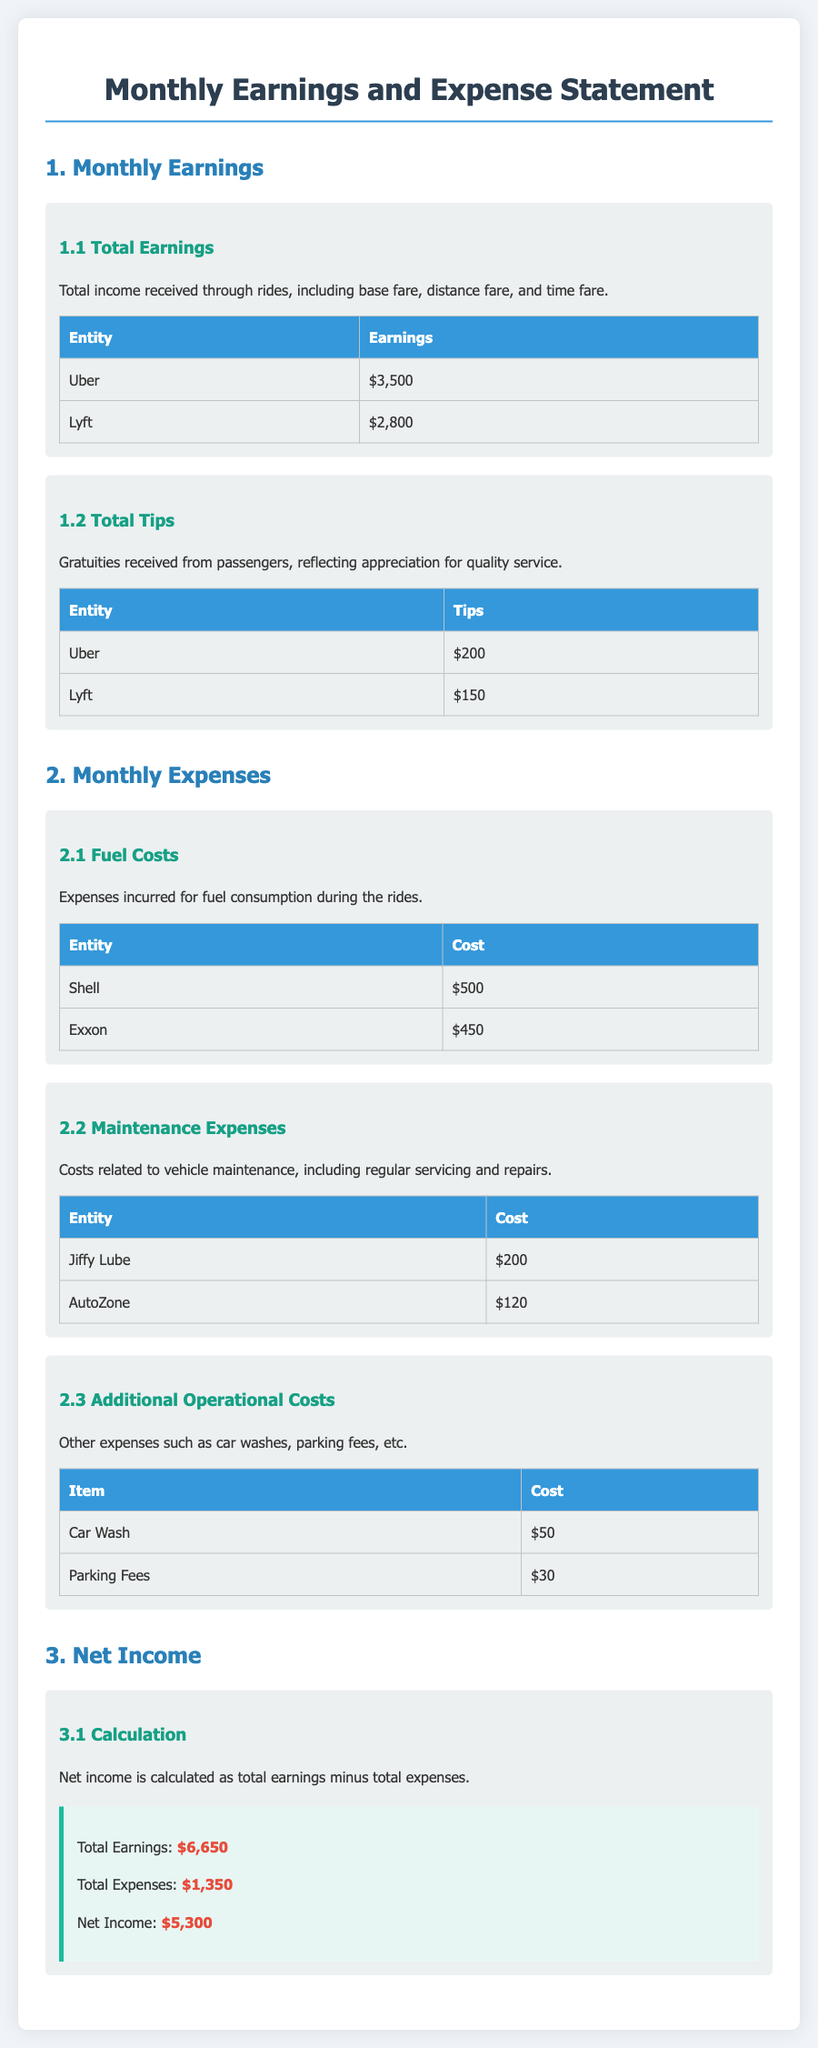What is the total earnings from Uber? The total earnings from Uber is listed in the document under total earnings, which is $3,500.
Answer: $3,500 What is the total tips received from Lyft? The total tips received from Lyft is detailed under total tips, which is $150.
Answer: $150 What are the fuel costs incurred from Shell? The fuel cost from Shell is stated in the expenses section, which is $500.
Answer: $500 What is the total amount spent on maintenance expenses? The total maintenance expenses are shown in the expenses section, with costs from Jiffy Lube and AutoZone combined, amounting to $320.
Answer: $320 What is the total income for the month? The total income is the sum of all earnings and tips, which equals $6,650.
Answer: $6,650 How much did the driver spend on parking fees? The document shows the cost for parking fees under additional operational costs, which is $30.
Answer: $30 What does net income represent? Net income is defined as the total earnings minus total expenses in the document.
Answer: Total earnings minus total expenses What is the total expenses for the month? The total expenses amount is directly provided at the calculation section, which is $1,350.
Answer: $1,350 What is the driver's net income? The net income is clearly stated in the calculation section, which is $5,300.
Answer: $5,300 